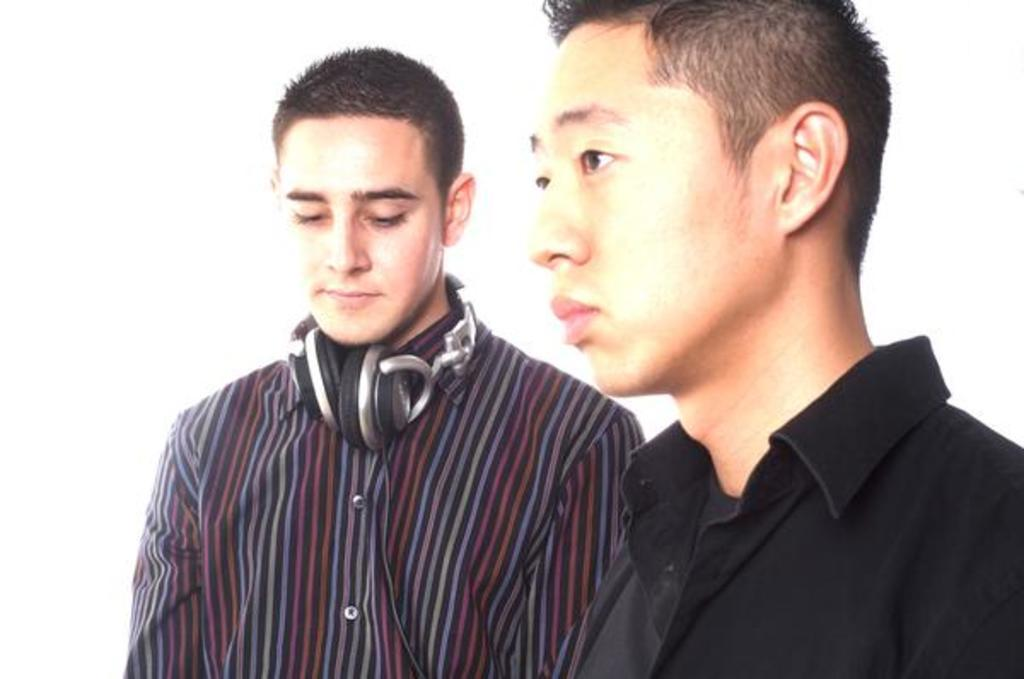What is the person in the image wearing? The person in the image is wearing a black shirt. Can you describe the other person in the image? The other person in the image is wearing headphones. What color is the background of the image? The background of the image is white. What type of humor can be heard coming from the harbor in the image? There is no harbor present in the image, and therefore no humor can be heard coming from it. 